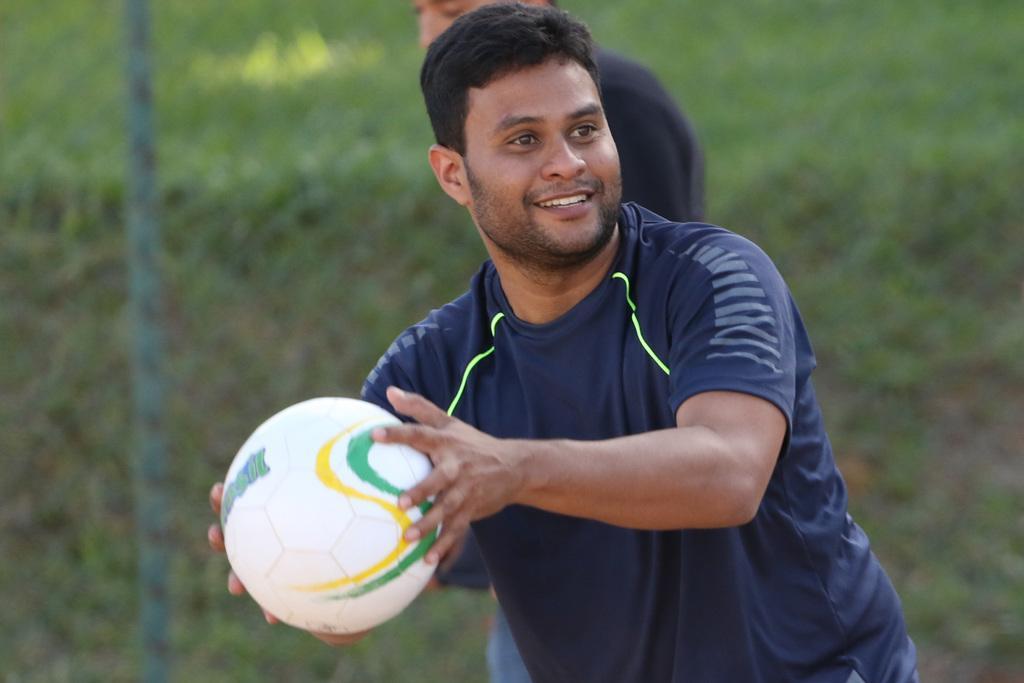How would you summarize this image in a sentence or two? This is a picture of man standing and smiling by holding a ball in his hand and behind him there is another person standing and at the back ground there is a grass and a iron grill and a pole. 